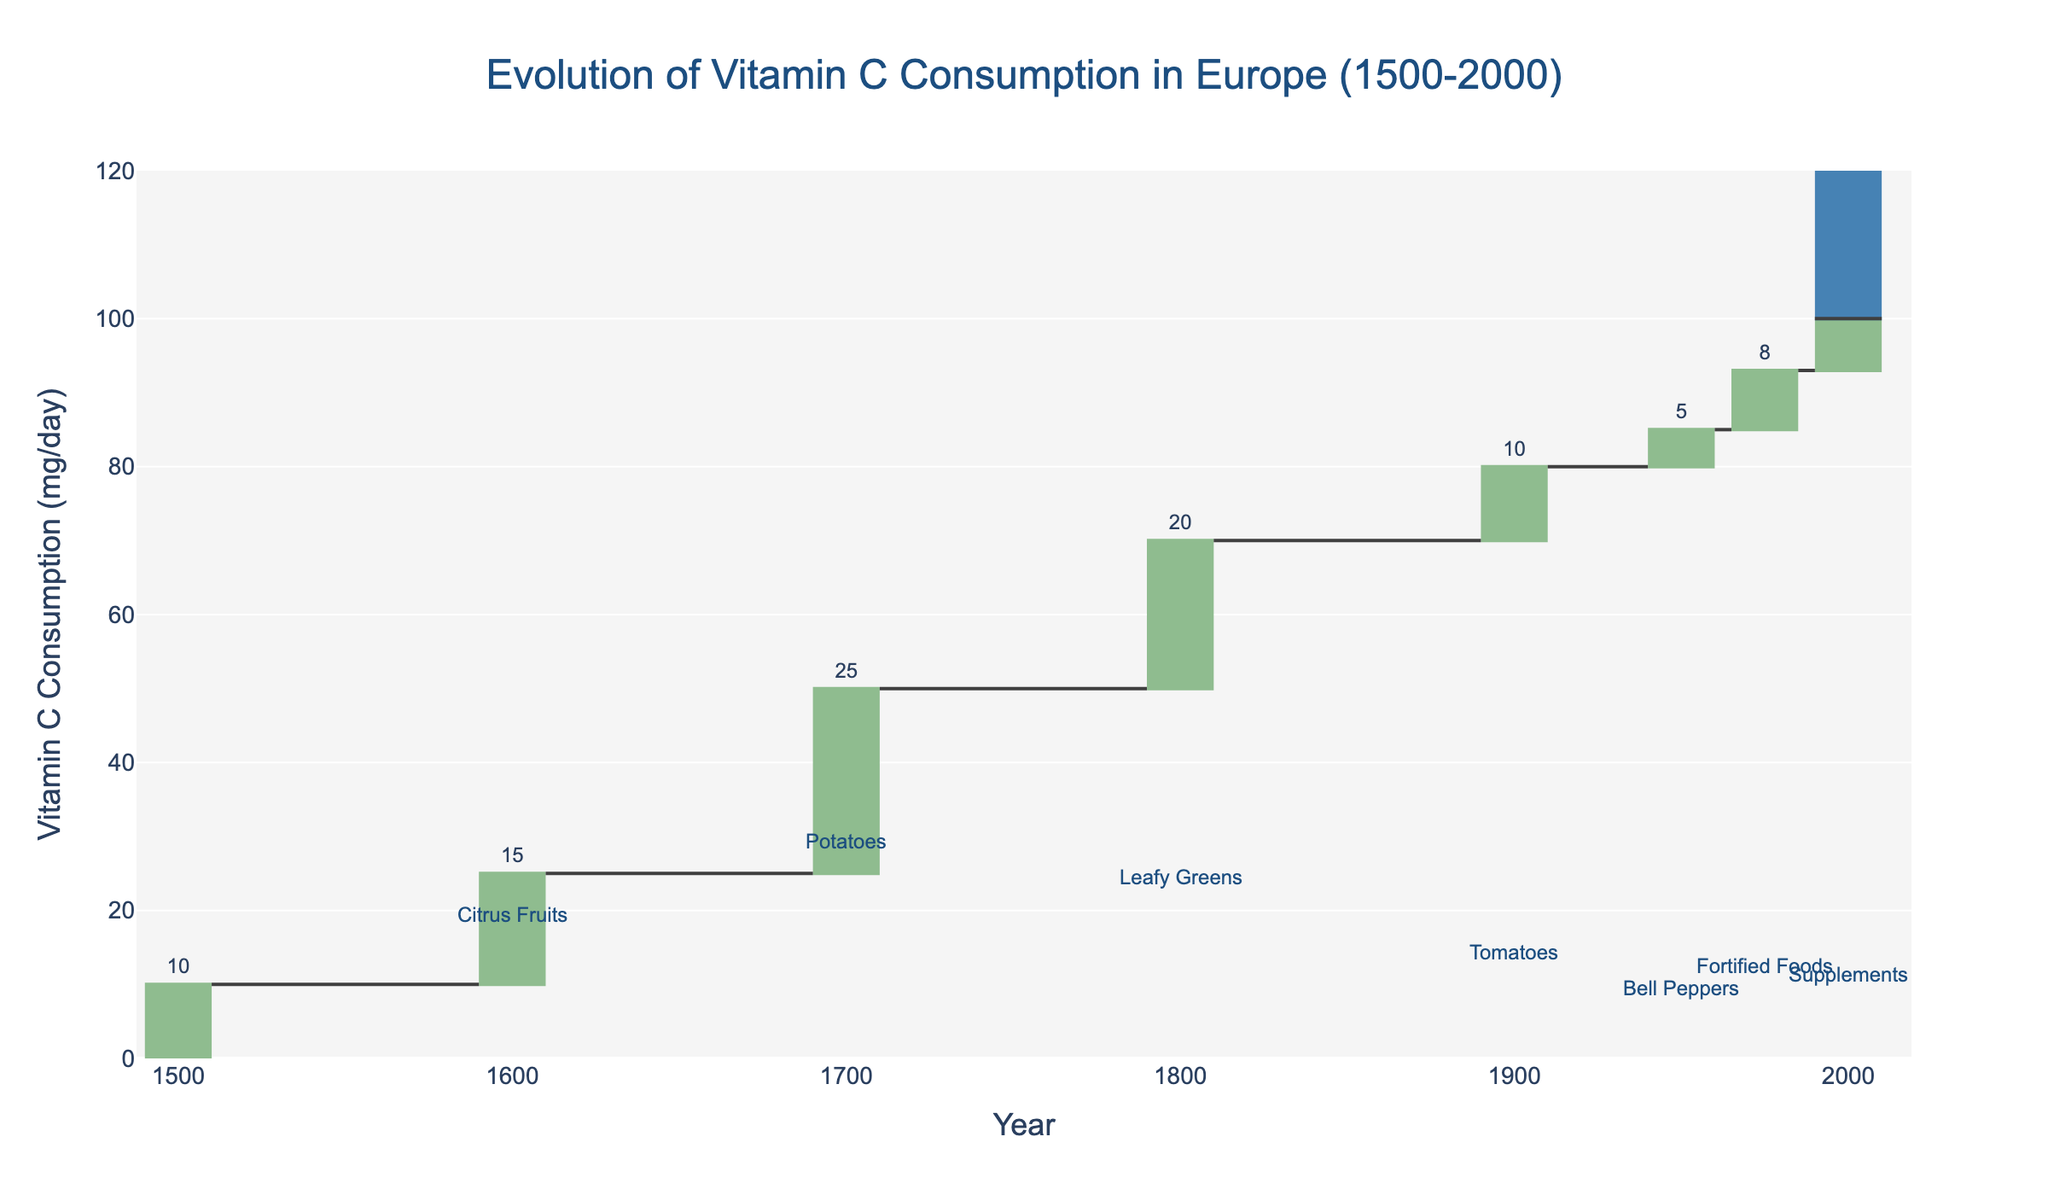What is the starting point of vitamin C consumption in Europe in 1500 according to the chart? The chart starts with a base value of vitamin C consumption, labeled as "Starting Point" in 1500, which is 10 mg/day.
Answer: 10 mg/day What is the title of the chart? The title of the chart is displayed at the top, and it reads "Evolution of Vitamin C Consumption in Europe (1500-2000)".
Answer: Evolution of Vitamin C Consumption in Europe (1500-2000) Which food source contributed the highest increase in vitamin C consumption according to the chart? By observing the columns representing the changes in vitamin C consumption, the column for "Potatoes" shows the highest value with an increase of 25 mg/day.
Answer: Potatoes In what year did fortified foods start contributing to vitamin C consumption in Europe? The chart shows an annotation above the year 1975, indicating that fortified foods started contributing to vitamin C consumption at that point.
Answer: 1975 How much did vitamin C consumption increase due to supplements in the year 2000? The annotation above the column for the year 2000 specifies that supplements contributed an increase of 7 mg/day.
Answer: 7 mg/day What was the total vitamin C consumption at the end of the observed period (2000)? The chart shows a total value with a bar labeled "Total" at the year 2000 which indicates vitamin C consumption was 100 mg/day at the end of the period.
Answer: 100 mg/day Compare the contributions from leafy greens and tomatoes; which one contributed more to vitamin C consumption and by how much? The chart shows that leafy greens contributed an increase of 20 mg/day and tomatoes contributed 10 mg/day. Therefore, leafy greens contributed 10 mg/day more.
Answer: Leafy greens by 10 mg/day What was the average increase in vitamin C consumption from 1500 to 2000 across all the different food sources listed? Sum the changes from all food sources (15 + 25 + 20 + 10 + 5 + 8 + 7 = 90 mg/day); there are 7 sources contributing, so the average increase is 90 mg/day / 7 = approximately 12.86 mg/day.
Answer: Approximately 12.86 mg/day How did vitamin C consumption change from 1600 to 1700, according to the chart? From 1600 to 1700, the chart shows increases of 15 mg/day from citrus fruits and 25 mg/day from potatoes respectively. The total change is 25 mg/day - 15 mg/day = 10 mg/day increase.
Answer: 10 mg/day increase 